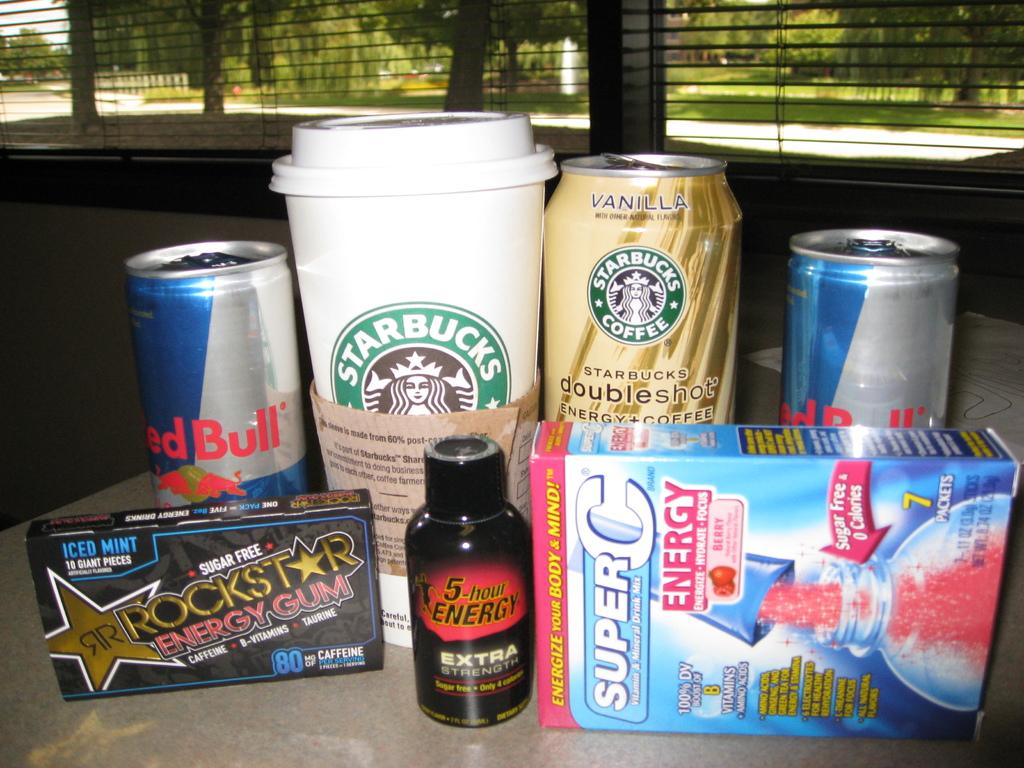Where is the large coffee cup from?
Your response must be concise. Starbucks. What flavor it the starbucks can?
Provide a succinct answer. Vanilla. 